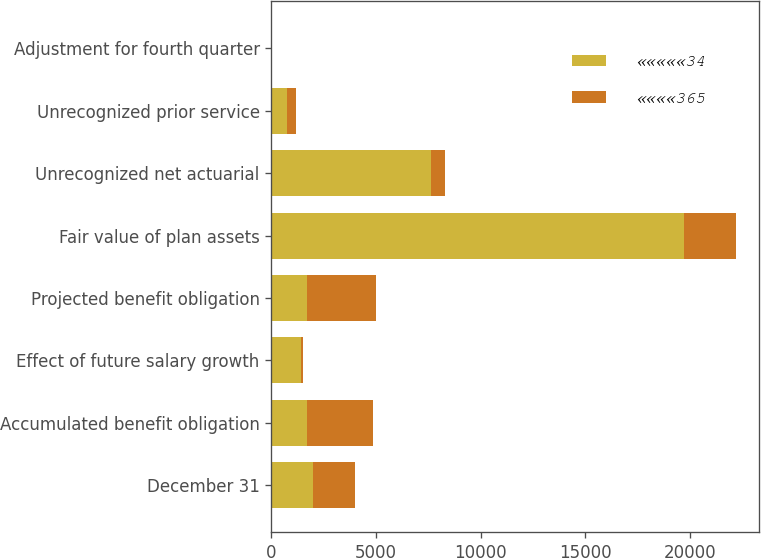Convert chart to OTSL. <chart><loc_0><loc_0><loc_500><loc_500><stacked_bar_chart><ecel><fcel>December 31<fcel>Accumulated benefit obligation<fcel>Effect of future salary growth<fcel>Projected benefit obligation<fcel>Fair value of plan assets<fcel>Unrecognized net actuarial<fcel>Unrecognized prior service<fcel>Adjustment for fourth quarter<nl><fcel>«««««34<fcel>2002<fcel>1697<fcel>1393<fcel>1697<fcel>19709<fcel>7651<fcel>770<fcel>7<nl><fcel>««««365<fcel>2001<fcel>3159<fcel>142<fcel>3301<fcel>2481<fcel>665<fcel>389<fcel>7<nl></chart> 